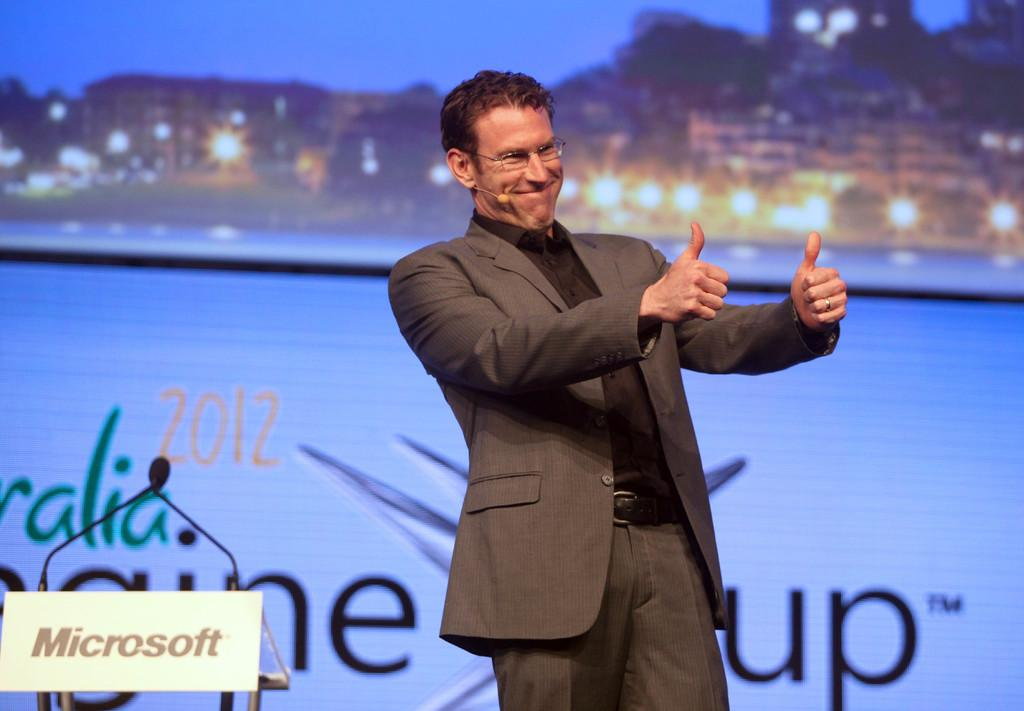What is the person in the image doing? The person is standing in the image and smiling. What can be seen in the background of the image? There is a banner, buildings, and lights visible in the background of the image. What is written on the banner? The banner has some text on it. How many bubbles can be seen floating around the person in the image? There are no bubbles present in the image. What type of expert is standing next to the person in the image? There is no expert present in the image; only the person and the background elements are visible. 